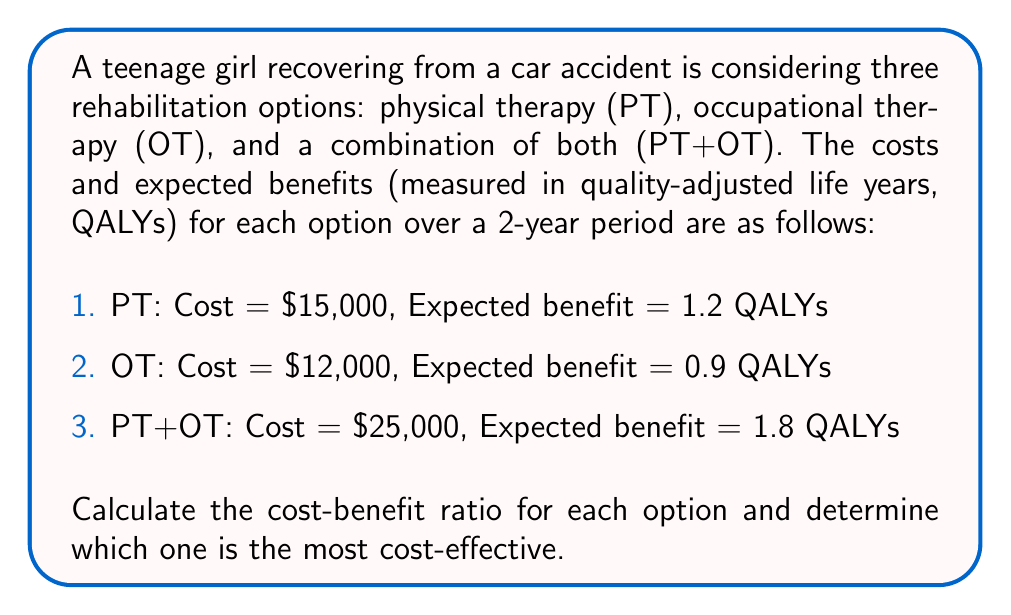Give your solution to this math problem. To solve this problem, we need to calculate the cost-benefit ratio for each option and compare them. The cost-benefit ratio is calculated by dividing the cost by the expected benefit.

1. For Physical Therapy (PT):
   Cost-benefit ratio = $\frac{\text{Cost}}{\text{Benefit}}$
   $$ \text{PT ratio} = \frac{\$15,000}{1.2 \text{ QALYs}} = \$12,500 \text{ per QALY} $$

2. For Occupational Therapy (OT):
   $$ \text{OT ratio} = \frac{\$12,000}{0.9 \text{ QALYs}} = \$13,333.33 \text{ per QALY} $$

3. For the combination of PT and OT:
   $$ \text{PT+OT ratio} = \frac{\$25,000}{1.8 \text{ QALYs}} = \$13,888.89 \text{ per QALY} $$

To determine the most cost-effective option, we compare the ratios. The lowest ratio indicates the most cost-effective option, as it provides the most benefit per dollar spent.

Comparing the ratios:
$\$12,500 < \$13,333.33 < \$13,888.89$

Therefore, Physical Therapy (PT) has the lowest cost-benefit ratio and is the most cost-effective option.
Answer: The most cost-effective rehabilitation option is Physical Therapy (PT) with a cost-benefit ratio of $\$12,500 \text{ per QALY}$. 